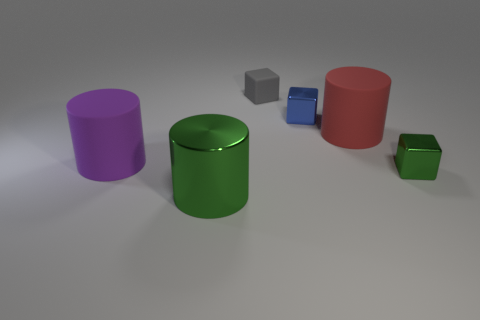Add 1 green objects. How many objects exist? 7 Add 4 red things. How many red things exist? 5 Subtract 0 blue balls. How many objects are left? 6 Subtract all yellow things. Subtract all blue metallic cubes. How many objects are left? 5 Add 2 large red matte objects. How many large red matte objects are left? 3 